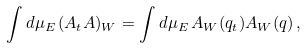Convert formula to latex. <formula><loc_0><loc_0><loc_500><loc_500>\int d \mu _ { E } \, ( A _ { t } A ) _ { W } = \int d \mu _ { E } \, A _ { W } ( { q } _ { t } ) A _ { W } ( { q } ) \, ,</formula> 